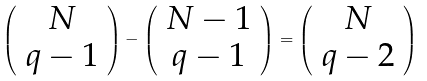Convert formula to latex. <formula><loc_0><loc_0><loc_500><loc_500>\left ( \begin{array} { c } N \\ q - 1 \end{array} \right ) - \left ( \begin{array} { c } N - 1 \\ q - 1 \end{array} \right ) = \left ( \begin{array} { c } N \\ q - 2 \end{array} \right )</formula> 